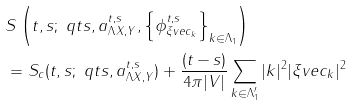Convert formula to latex. <formula><loc_0><loc_0><loc_500><loc_500>& S \left ( t , s ; \ q t s , a _ { \Lambda X , Y } ^ { t , s } , \left \{ \phi _ { \xi v e c _ { k } } ^ { t , s } \right \} _ { k \in \Lambda _ { 1 } } \right ) \\ & = S _ { c } ( t , s ; \ q t s , a _ { \Lambda X , Y } ^ { t , s } ) + \frac { ( t - s ) } { 4 \pi | V | } \sum _ { k \in \Lambda ^ { \prime } _ { 1 } } | k | ^ { 2 } | \xi v e c _ { k } | ^ { 2 }</formula> 